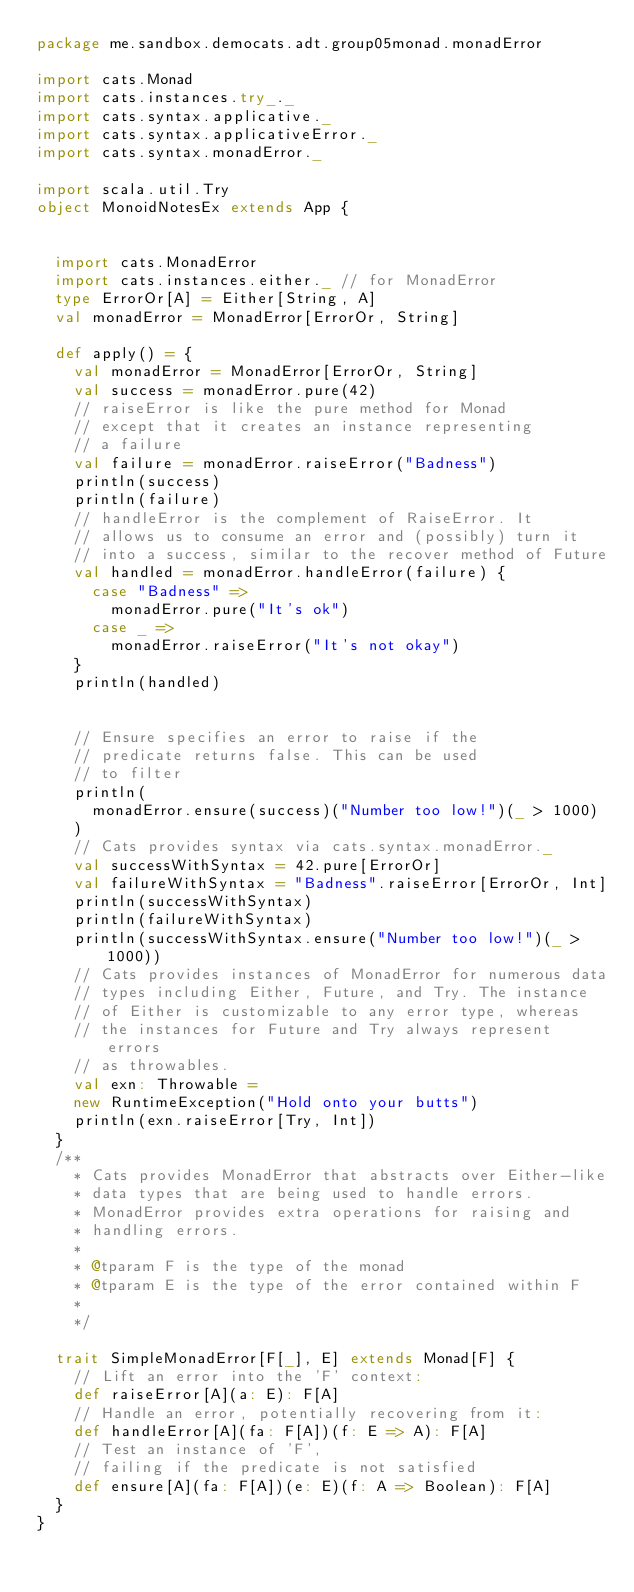Convert code to text. <code><loc_0><loc_0><loc_500><loc_500><_Scala_>package me.sandbox.democats.adt.group05monad.monadError

import cats.Monad
import cats.instances.try_._
import cats.syntax.applicative._
import cats.syntax.applicativeError._
import cats.syntax.monadError._

import scala.util.Try
object MonoidNotesEx extends App {


  import cats.MonadError
  import cats.instances.either._ // for MonadError
  type ErrorOr[A] = Either[String, A]
  val monadError = MonadError[ErrorOr, String]

  def apply() = {
    val monadError = MonadError[ErrorOr, String]
    val success = monadError.pure(42)
    // raiseError is like the pure method for Monad
    // except that it creates an instance representing
    // a failure
    val failure = monadError.raiseError("Badness")
    println(success)
    println(failure)
    // handleError is the complement of RaiseError. It
    // allows us to consume an error and (possibly) turn it
    // into a success, similar to the recover method of Future
    val handled = monadError.handleError(failure) {
      case "Badness" =>
        monadError.pure("It's ok")
      case _ =>
        monadError.raiseError("It's not okay")
    }
    println(handled)


    // Ensure specifies an error to raise if the
    // predicate returns false. This can be used
    // to filter
    println(
      monadError.ensure(success)("Number too low!")(_ > 1000)
    )
    // Cats provides syntax via cats.syntax.monadError._
    val successWithSyntax = 42.pure[ErrorOr]
    val failureWithSyntax = "Badness".raiseError[ErrorOr, Int]
    println(successWithSyntax)
    println(failureWithSyntax)
    println(successWithSyntax.ensure("Number too low!")(_ > 1000))
    // Cats provides instances of MonadError for numerous data
    // types including Either, Future, and Try. The instance
    // of Either is customizable to any error type, whereas
    // the instances for Future and Try always represent errors
    // as throwables.
    val exn: Throwable =
    new RuntimeException("Hold onto your butts")
    println(exn.raiseError[Try, Int])
  }
  /**
    * Cats provides MonadError that abstracts over Either-like
    * data types that are being used to handle errors.
    * MonadError provides extra operations for raising and
    * handling errors.
    *
    * @tparam F is the type of the monad
    * @tparam E is the type of the error contained within F
    *
    */

  trait SimpleMonadError[F[_], E] extends Monad[F] {
    // Lift an error into the 'F' context:
    def raiseError[A](a: E): F[A]
    // Handle an error, potentially recovering from it:
    def handleError[A](fa: F[A])(f: E => A): F[A]
    // Test an instance of 'F',
    // failing if the predicate is not satisfied
    def ensure[A](fa: F[A])(e: E)(f: A => Boolean): F[A]
  }
}

</code> 